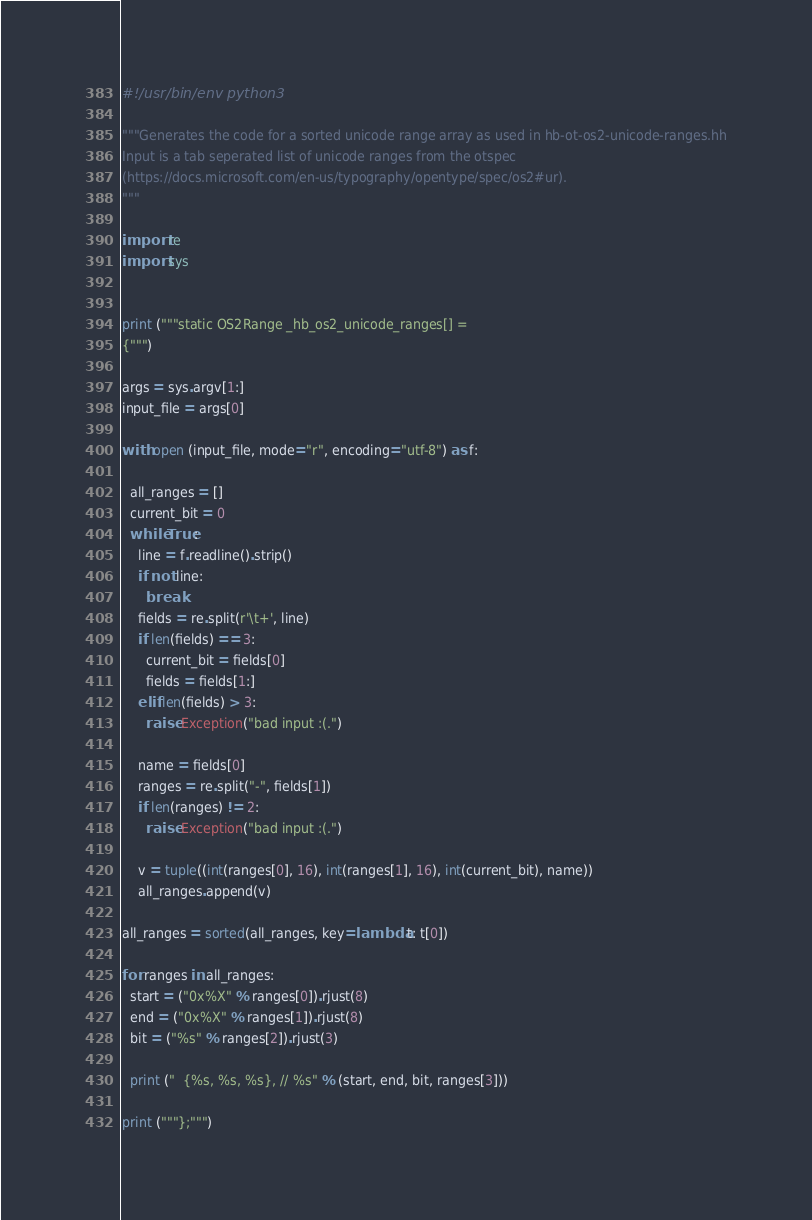Convert code to text. <code><loc_0><loc_0><loc_500><loc_500><_Python_>#!/usr/bin/env python3

"""Generates the code for a sorted unicode range array as used in hb-ot-os2-unicode-ranges.hh
Input is a tab seperated list of unicode ranges from the otspec
(https://docs.microsoft.com/en-us/typography/opentype/spec/os2#ur).
"""

import re
import sys


print ("""static OS2Range _hb_os2_unicode_ranges[] =
{""")

args = sys.argv[1:]
input_file = args[0]

with open (input_file, mode="r", encoding="utf-8") as f:

  all_ranges = []
  current_bit = 0
  while True:
    line = f.readline().strip()
    if not line:
      break
    fields = re.split(r'\t+', line)
    if len(fields) == 3:
      current_bit = fields[0]
      fields = fields[1:]
    elif len(fields) > 3:
      raise Exception("bad input :(.")

    name = fields[0]
    ranges = re.split("-", fields[1])
    if len(ranges) != 2:
      raise Exception("bad input :(.")

    v = tuple((int(ranges[0], 16), int(ranges[1], 16), int(current_bit), name))
    all_ranges.append(v)

all_ranges = sorted(all_ranges, key=lambda t: t[0])

for ranges in all_ranges:
  start = ("0x%X" % ranges[0]).rjust(8)
  end = ("0x%X" % ranges[1]).rjust(8)
  bit = ("%s" % ranges[2]).rjust(3)

  print ("  {%s, %s, %s}, // %s" % (start, end, bit, ranges[3]))

print ("""};""")
</code> 